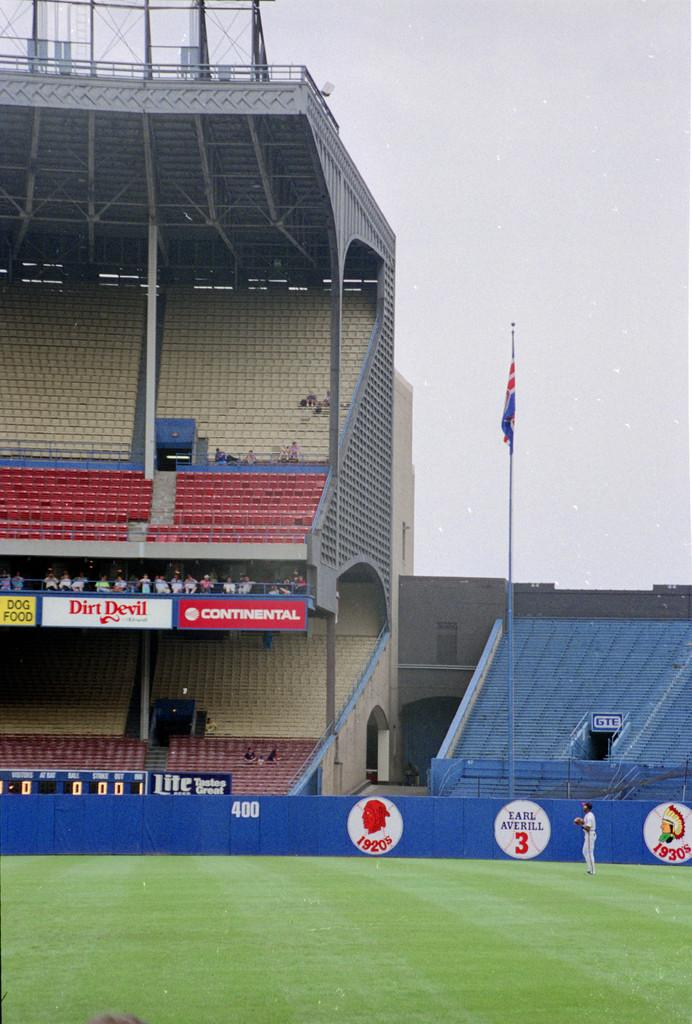Provide a one-sentence caption for the provided image. a blue wall with the number 3 on a baseball graphic. 